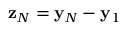<formula> <loc_0><loc_0><loc_500><loc_500>{ z } _ { N } = { y } _ { N } - { y } _ { 1 }</formula> 